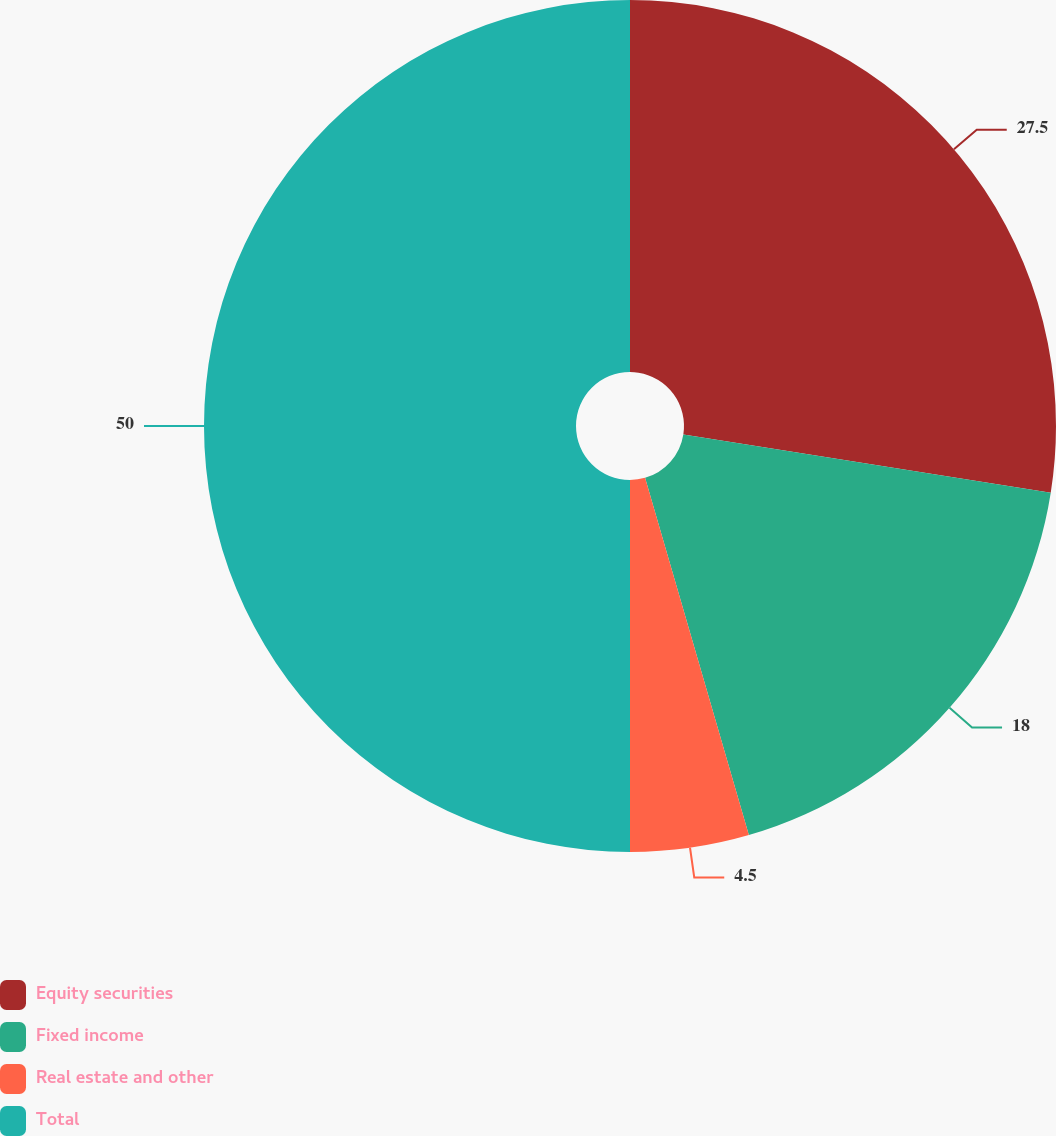<chart> <loc_0><loc_0><loc_500><loc_500><pie_chart><fcel>Equity securities<fcel>Fixed income<fcel>Real estate and other<fcel>Total<nl><fcel>27.5%<fcel>18.0%<fcel>4.5%<fcel>50.0%<nl></chart> 